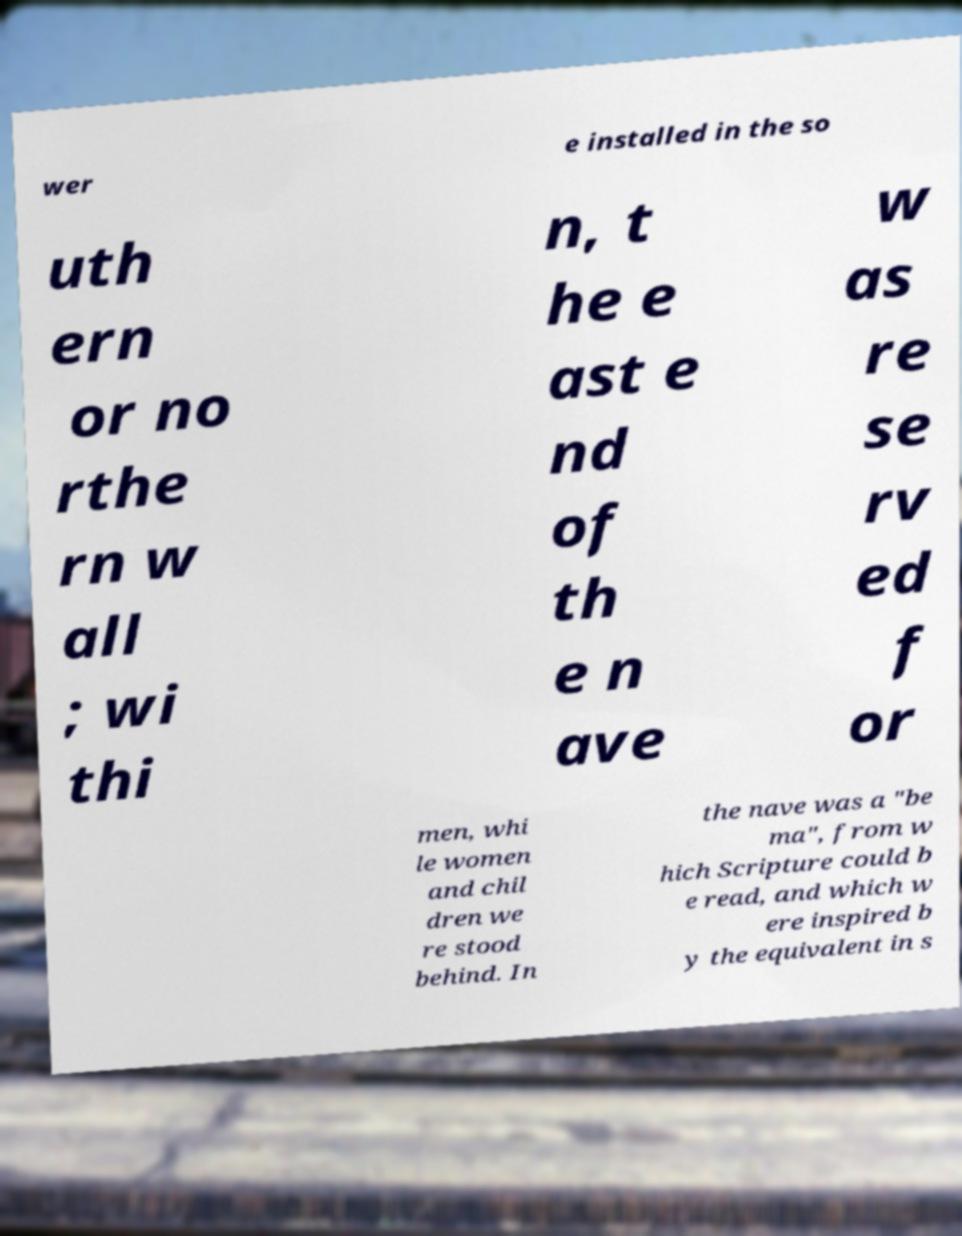There's text embedded in this image that I need extracted. Can you transcribe it verbatim? wer e installed in the so uth ern or no rthe rn w all ; wi thi n, t he e ast e nd of th e n ave w as re se rv ed f or men, whi le women and chil dren we re stood behind. In the nave was a "be ma", from w hich Scripture could b e read, and which w ere inspired b y the equivalent in s 